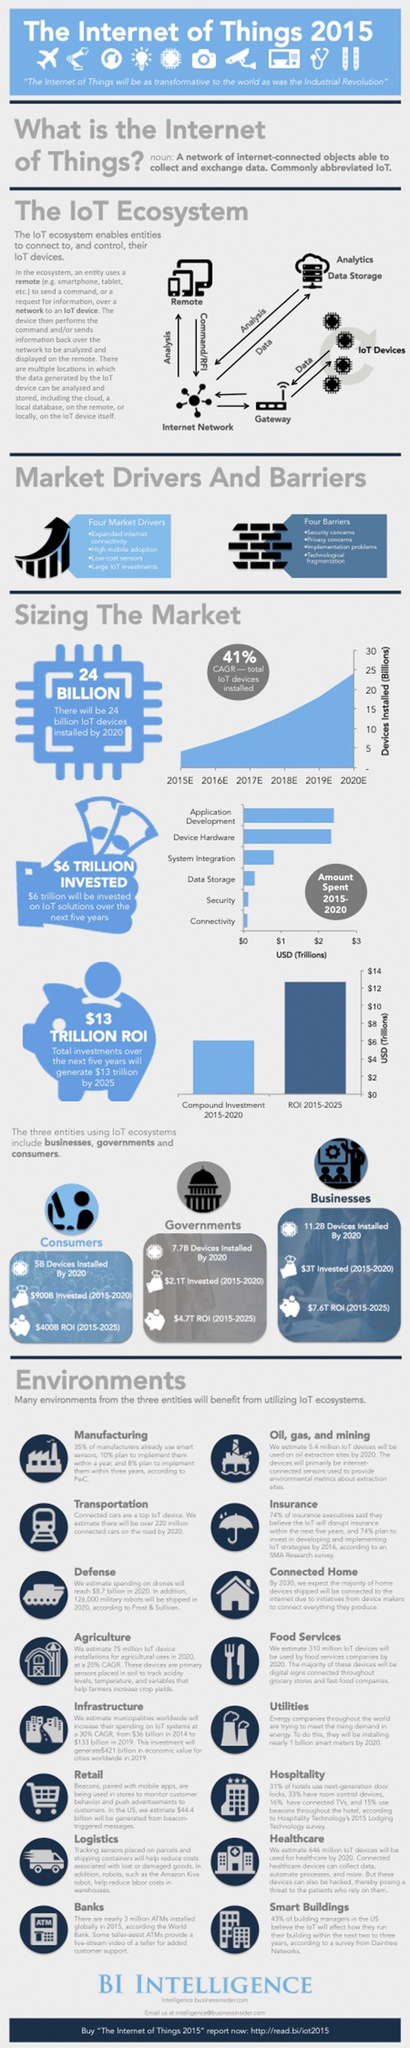Specify some key components in this picture. According to estimates, businesses invested approximately $3 trillion on IoT solutions from 2015 to 2020. The return on investment for the Internet of Things in businesses during the period of 2015-2020 is expected to be approximately $7.6 trillion. By 2020, it is expected that 7.7 billion IoT devices will be installed in the government sector. 